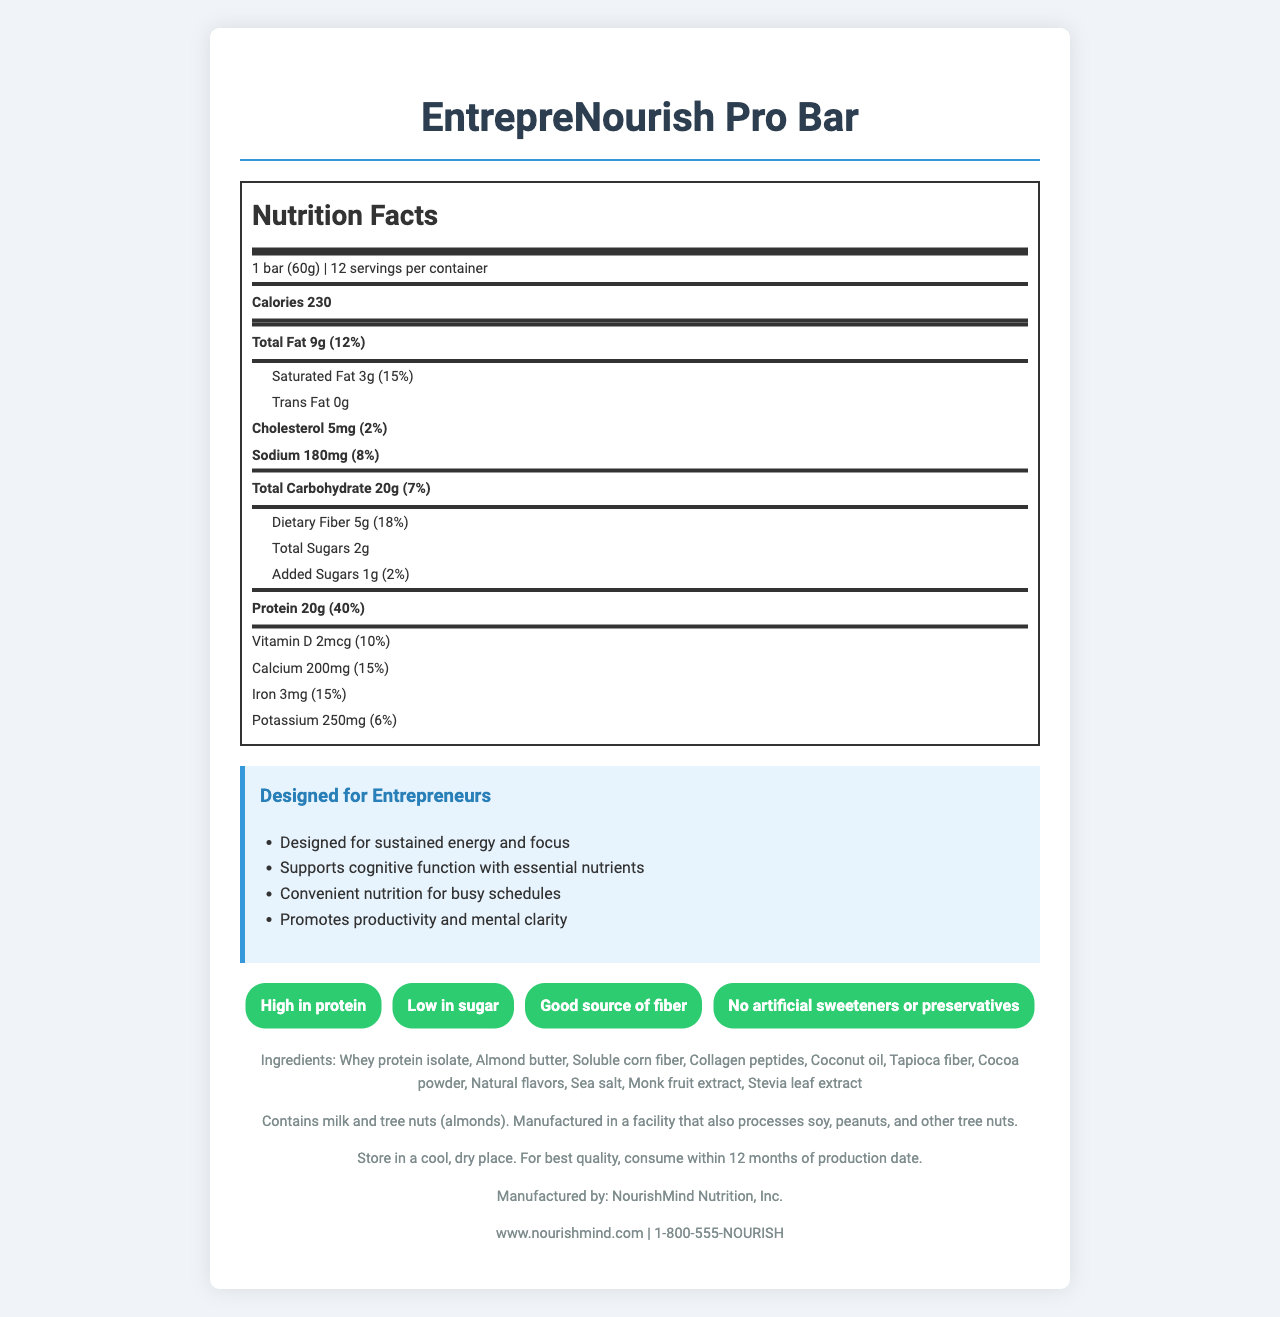what is the serving size of the EntrepreNourish Pro Bar? The label indicates that the serving size is "1 bar (60g)".
Answer: 1 bar (60g) how many calories are in one serving of the EntrepreNourish Pro Bar? The label shows that each serving (one bar) contains 230 calories.
Answer: 230 calories what is the total fat content per serving? The label specifies that the total fat content per serving is 9g.
Answer: 9g how much protein is in one serving of the bar? The label states that there are 20g of protein in one serving.
Answer: 20g what are the types of allergens mentioned? The allergen information on the label mentions that the product contains milk and tree nuts (almonds).
Answer: Milk and tree nuts (almonds) how many servings are there per container of the EntrepreNourish Pro Bar? The label mentions that there are 12 servings per container.
Answer: 12 servings what is the daily value percentage for dietary fiber in the EntrepreNourish Pro Bar? The label indicates an 18% daily value for dietary fiber per serving.
Answer: 18% how much added sugar does one bar contain? The label shows that each bar contains 1g of added sugars.
Answer: 1g which of the following is not listed as an ingredient in the EntrepreNourish Pro Bar? A. Whey Protein Isolate B. Almond Butter C. Cane Sugar The listed ingredients do not include cane sugar.
Answer: C. Cane Sugar what is the main idea of this document? The document describes the EntrepreNourish Pro Bar, a high-protein, low-carb meal replacement bar with various nutritional details, health claims, ingredients, and allergen information. It emphasizes benefits for busy entrepreneurs, such as sustained energy, cognitive support, and convenience.
Answer: A nutritious meal replacement bar designed for busy entrepreneurs which nutrient is present in the highest amount per serving, according to the percent daily value? A. Protein B. Total Fat C. Sodium D. Dietary Fiber The percent daily value for protein is the highest at 40%.
Answer: A. Protein are there any artificial sweeteners or preservatives in the EntrepreNourish Pro Bar? The document contains a health claim stating "No artificial sweeteners or preservatives".
Answer: No does the EntrepreNourish Pro Bar contain any trans fat? The label states that the trans fat content is 0g.
Answer: No is this product suitable for someone with a soy allergy? The allergen information mentions that the product is manufactured in a facility that also processes soy, which might pose a risk to someone with a soy allergy.
Answer: Maybe not what is the manufacturer's name of the EntrepreNourish Pro Bar? The footer of the document states that the product is manufactured by NourishMind Nutrition, Inc.
Answer: NourishMind Nutrition, Inc. what effect can the EntrepreNourish Pro Bar have on cognitive function? The section designed for entrepreneurs lists "Supports cognitive function with essential nutrients" as one of the focus points.
Answer: Supports cognitive function with essential nutrients how many grams of dietary fiber per serving does the EntrepreNourish Pro Bar have? The label shows that there are 5g of dietary fiber per serving.
Answer: 5g what additional instructions are provided for storage of the bar? The storage instructions state to store in a cool, dry place and consume within 12 months for best quality.
Answer: Store in a cool, dry place. For best quality, consume within 12 months of production date. does the EntrepreNourish Pro Bar contain potassium? If so, how much? The label shows that each serving contains 250mg of potassium.
Answer: Yes, 250mg how does the product aim to benefit busy entrepreneurs? The section designed for entrepreneurs lists benefits like sustained energy, cognitive support, convenience, and mental clarity.
Answer: Designed for sustained energy and focus, supports cognitive function, convenient nutrition for busy schedules, promotes productivity and mental clarity what is the product name? The top of the document clearly states the product name as EntrepreNourish Pro Bar.
Answer: EntrepreNourish Pro Bar what are the natural sweeteners used in the EntrepreNourish Pro Bar? The ingredients list includes monk fruit extract and stevia leaf extract as natural sweeteners.
Answer: Monk fruit extract, Stevia leaf extract is the amount of sugar higher or lower than the amount of dietary fiber in one bar? The label shows each bar contains 2g of total sugars and 5g of dietary fiber, so the sugar content is lower than the dietary fiber content.
Answer: Lower how should you consume this product for the best quality? The storage instructions recommend consuming the product within 12 months of the production date for best quality.
Answer: Consume within 12 months of production date how many grams of carbohydrates are in one bar? The label shows that each serving contains 20g of total carbohydrates.
Answer: 20g what is the total daily value percentage provided by iron in the EntrepreNourish Pro Bar? The label indicates that the iron content provides 15% of the daily value per serving.
Answer: 15% is there any cholesterol in one bar of EntrepreNourish Pro Bar? The label mentions that each bar contains 5mg of cholesterol.
Answer: Yes, 5mg what is the main source of protein in the EntrepreNourish Pro Bar? The ingredients list indicates whey protein isolate as the main source of protein.
Answer: Whey protein isolate what is the sugar content in one serving of the bar, including added sugars? The total sugar content includes 2g of total sugars and 1g of added sugars, summing up to 3g.
Answer: 3g what is the effect of the EntrepreNourish Pro Bar on blood pressure? The document does not provide information regarding the effect of the EntrepreNourish Pro Bar on blood pressure.
Answer: Cannot be determined 